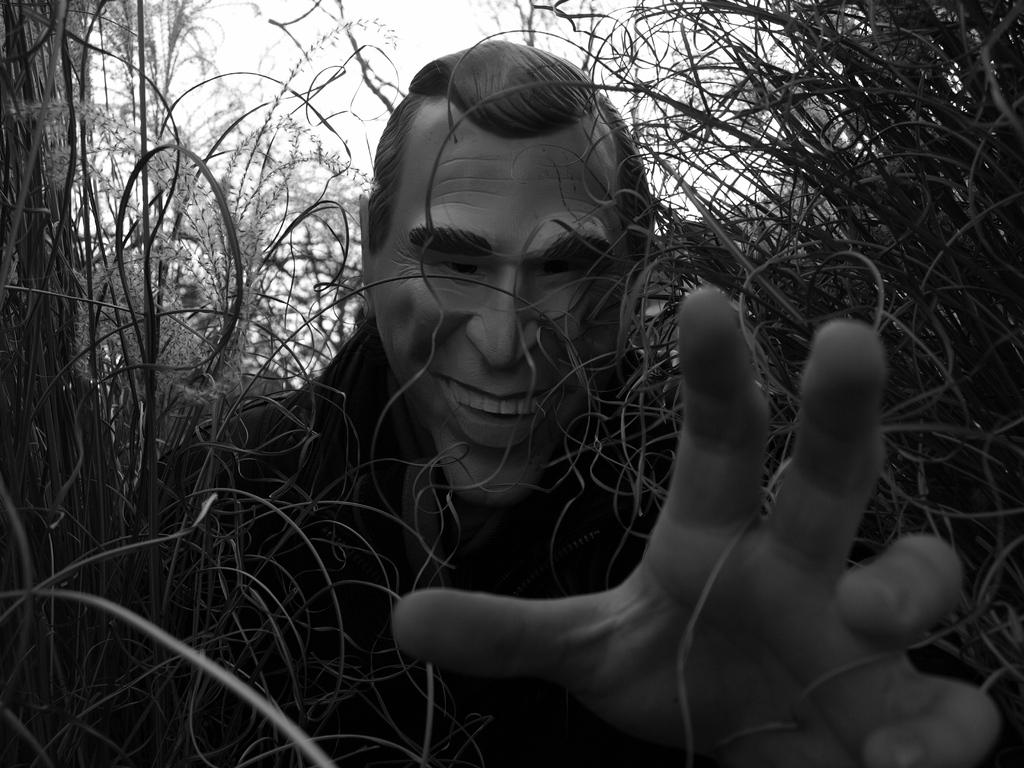What is the color scheme of the image? The image is black and white. What is the main subject of the image? There is a person's statue in the image. Can you describe the hand in the image? A hand is visible in the right bottom corner of the image. What type of vegetation is present around the statue? Grass and plants are visible around the statue. What type of food is the cook preparing for the sisters in the image? There is no cook, food, or sisters present in the image; it features a statue and vegetation. 